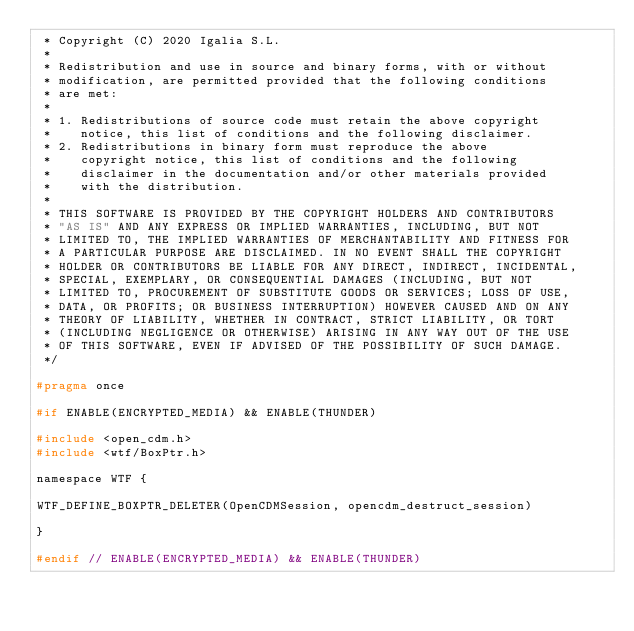<code> <loc_0><loc_0><loc_500><loc_500><_C_> * Copyright (C) 2020 Igalia S.L.
 *
 * Redistribution and use in source and binary forms, with or without
 * modification, are permitted provided that the following conditions
 * are met:
 *
 * 1. Redistributions of source code must retain the above copyright
 *    notice, this list of conditions and the following disclaimer.
 * 2. Redistributions in binary form must reproduce the above
 *    copyright notice, this list of conditions and the following
 *    disclaimer in the documentation and/or other materials provided
 *    with the distribution.
 *
 * THIS SOFTWARE IS PROVIDED BY THE COPYRIGHT HOLDERS AND CONTRIBUTORS
 * "AS IS" AND ANY EXPRESS OR IMPLIED WARRANTIES, INCLUDING, BUT NOT
 * LIMITED TO, THE IMPLIED WARRANTIES OF MERCHANTABILITY AND FITNESS FOR
 * A PARTICULAR PURPOSE ARE DISCLAIMED. IN NO EVENT SHALL THE COPYRIGHT
 * HOLDER OR CONTRIBUTORS BE LIABLE FOR ANY DIRECT, INDIRECT, INCIDENTAL,
 * SPECIAL, EXEMPLARY, OR CONSEQUENTIAL DAMAGES (INCLUDING, BUT NOT
 * LIMITED TO, PROCUREMENT OF SUBSTITUTE GOODS OR SERVICES; LOSS OF USE,
 * DATA, OR PROFITS; OR BUSINESS INTERRUPTION) HOWEVER CAUSED AND ON ANY
 * THEORY OF LIABILITY, WHETHER IN CONTRACT, STRICT LIABILITY, OR TORT
 * (INCLUDING NEGLIGENCE OR OTHERWISE) ARISING IN ANY WAY OUT OF THE USE
 * OF THIS SOFTWARE, EVEN IF ADVISED OF THE POSSIBILITY OF SUCH DAMAGE.
 */

#pragma once

#if ENABLE(ENCRYPTED_MEDIA) && ENABLE(THUNDER)

#include <open_cdm.h>
#include <wtf/BoxPtr.h>

namespace WTF {

WTF_DEFINE_BOXPTR_DELETER(OpenCDMSession, opencdm_destruct_session)

}

#endif // ENABLE(ENCRYPTED_MEDIA) && ENABLE(THUNDER)
</code> 